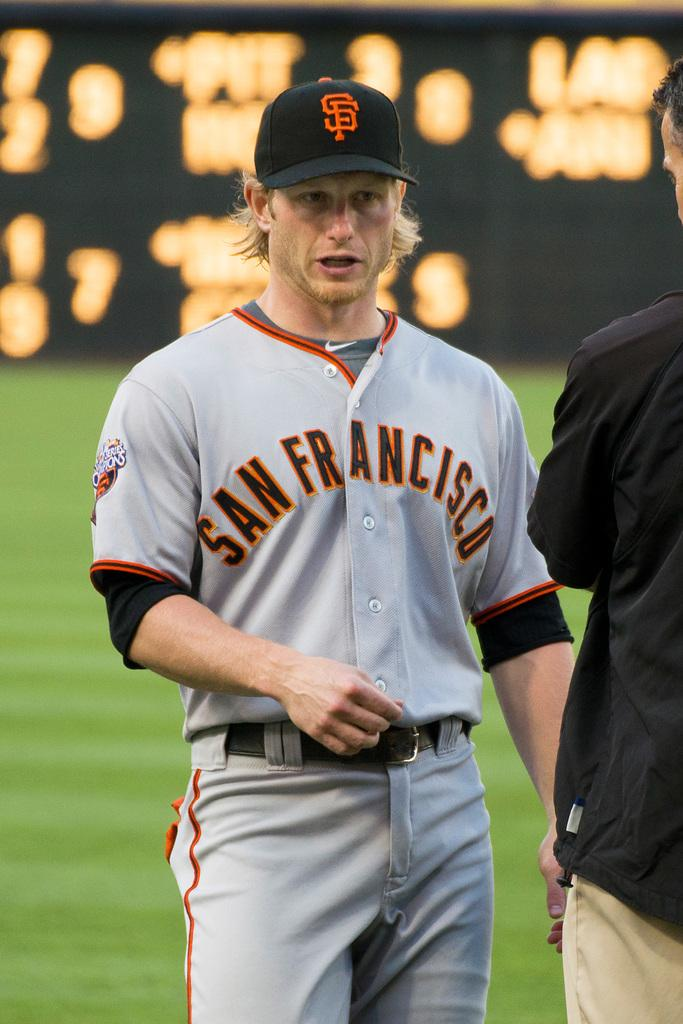<image>
Summarize the visual content of the image. A player in a grey jersey with San Francisco written on it 